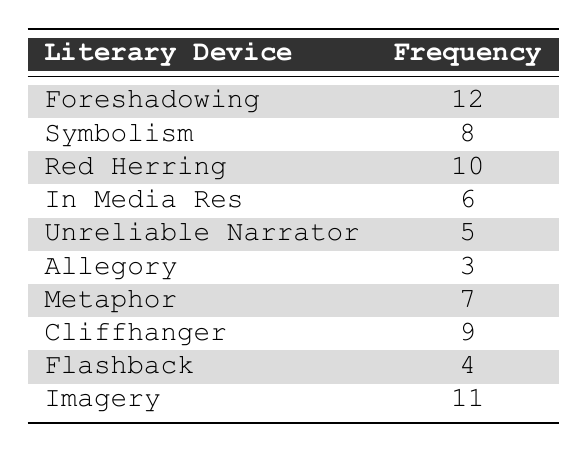What is the frequency of Foreshadowing? The table lists the literary device "Foreshadowing" with a frequency of 12.
Answer: 12 Which literary device has the highest frequency? Looking at the frequencies, "Foreshadowing" has the highest value of 12 compared to other devices.
Answer: Foreshadowing What is the frequency of Symbolism? The table indicates that the frequency of "Symbolism" is 8.
Answer: 8 How many more instances of Imagery are there than Allegory? The frequency of "Imagery" is 11 and "Allegory" is 3. The difference is calculated as 11 - 3 = 8.
Answer: 8 True or False: The frequency of Unreliable Narrator is greater than 6. The table shows that the frequency of "Unreliable Narrator" is 5, which is not greater than 6.
Answer: False What is the total frequency of all literary devices listed in the table? To find the total, we sum up all frequencies: 12 + 8 + 10 + 6 + 5 + 3 + 7 + 9 + 4 + 11 = 75.
Answer: 75 How many literary devices have a frequency greater than 7? The devices with a frequency greater than 7 are Foreshadowing (12), Red Herring (10), Imagery (11), Cliffhanger (9), and Metaphor (7). Thus, five literary devices meet this criterion.
Answer: 5 What percentage of the total frequency does the frequency of Flashback represent? The frequency of Flashback is 4. To find the percentage, we divide 4 by the total frequency (75) and multiply by 100: (4 / 75) * 100 ≈ 5.33%.
Answer: Approximately 5.33% Which literary device appears the least in the provided list? The frequency of "Allegory" is 3, which is the lowest among all literary devices listed.
Answer: Allegory 